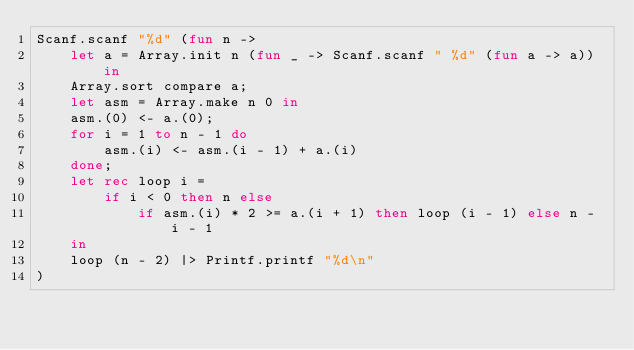<code> <loc_0><loc_0><loc_500><loc_500><_OCaml_>Scanf.scanf "%d" (fun n ->
    let a = Array.init n (fun _ -> Scanf.scanf " %d" (fun a -> a)) in
    Array.sort compare a;
    let asm = Array.make n 0 in
    asm.(0) <- a.(0);
    for i = 1 to n - 1 do
        asm.(i) <- asm.(i - 1) + a.(i)
    done;
    let rec loop i =
        if i < 0 then n else
            if asm.(i) * 2 >= a.(i + 1) then loop (i - 1) else n - i - 1
    in
    loop (n - 2) |> Printf.printf "%d\n"
)</code> 